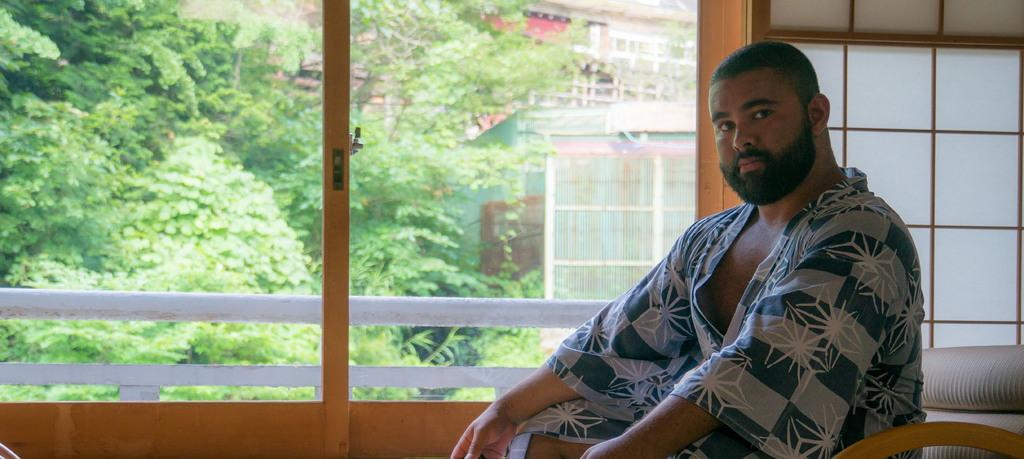What is the person in the image doing? The person is sitting on a chair in the image. What type of structure is present in the image? There is a glass window in the image. What can be seen outside the window? Trees are visible in the image. What type of structures are present in the background? Buildings are present in the image. What type of quill is the person using to write on the oven in the image? There is no quill or oven present in the image. 